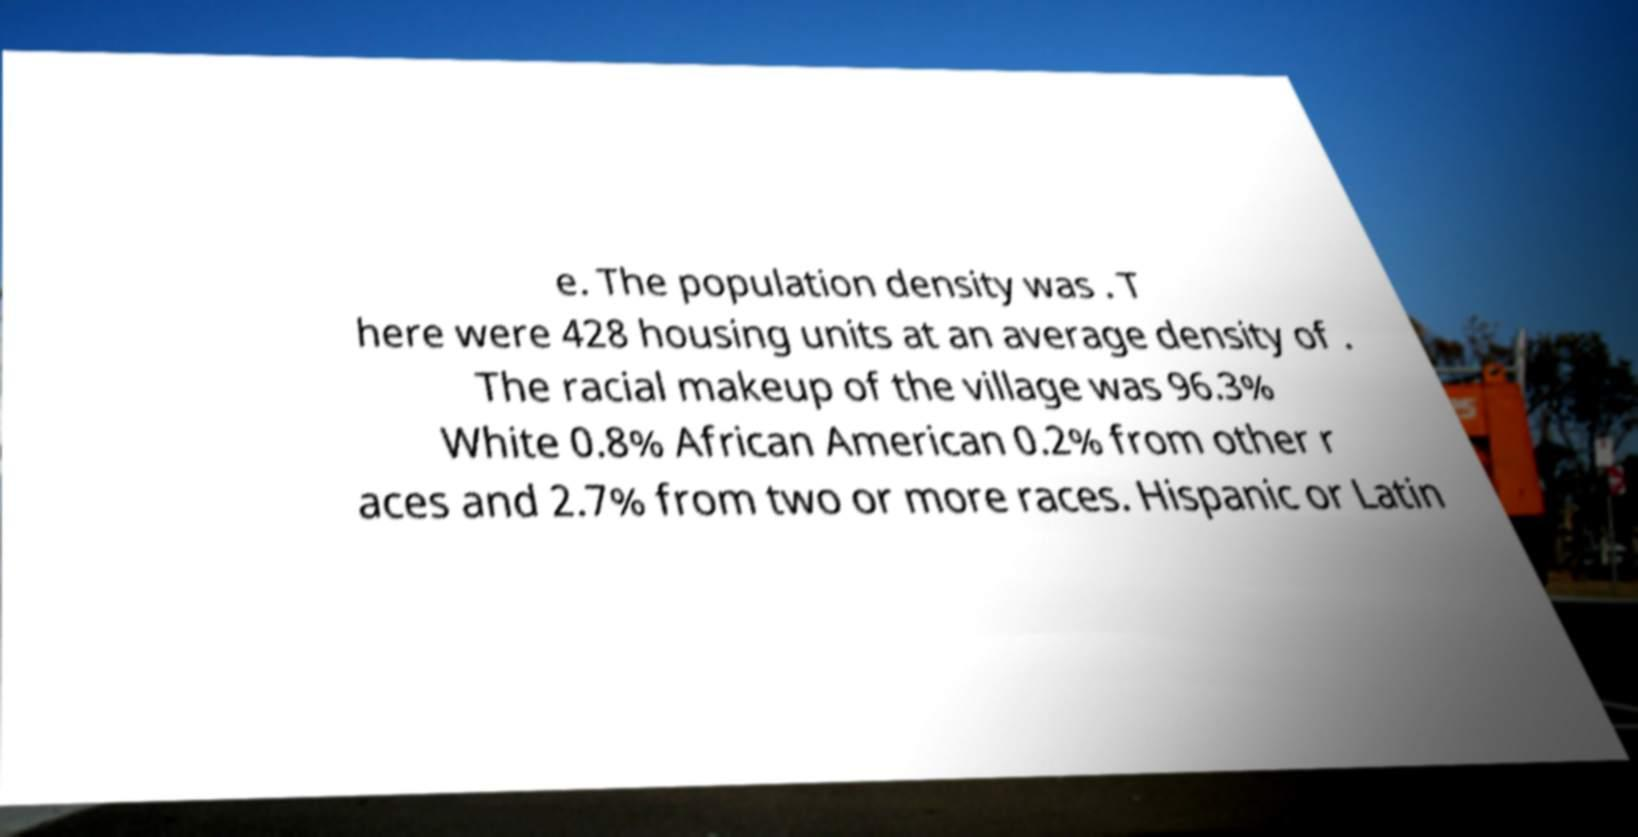Can you accurately transcribe the text from the provided image for me? e. The population density was . T here were 428 housing units at an average density of . The racial makeup of the village was 96.3% White 0.8% African American 0.2% from other r aces and 2.7% from two or more races. Hispanic or Latin 